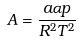<formula> <loc_0><loc_0><loc_500><loc_500>A = \frac { a \alpha p } { R ^ { 2 } T ^ { 2 } }</formula> 